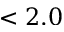Convert formula to latex. <formula><loc_0><loc_0><loc_500><loc_500>< 2 . 0</formula> 